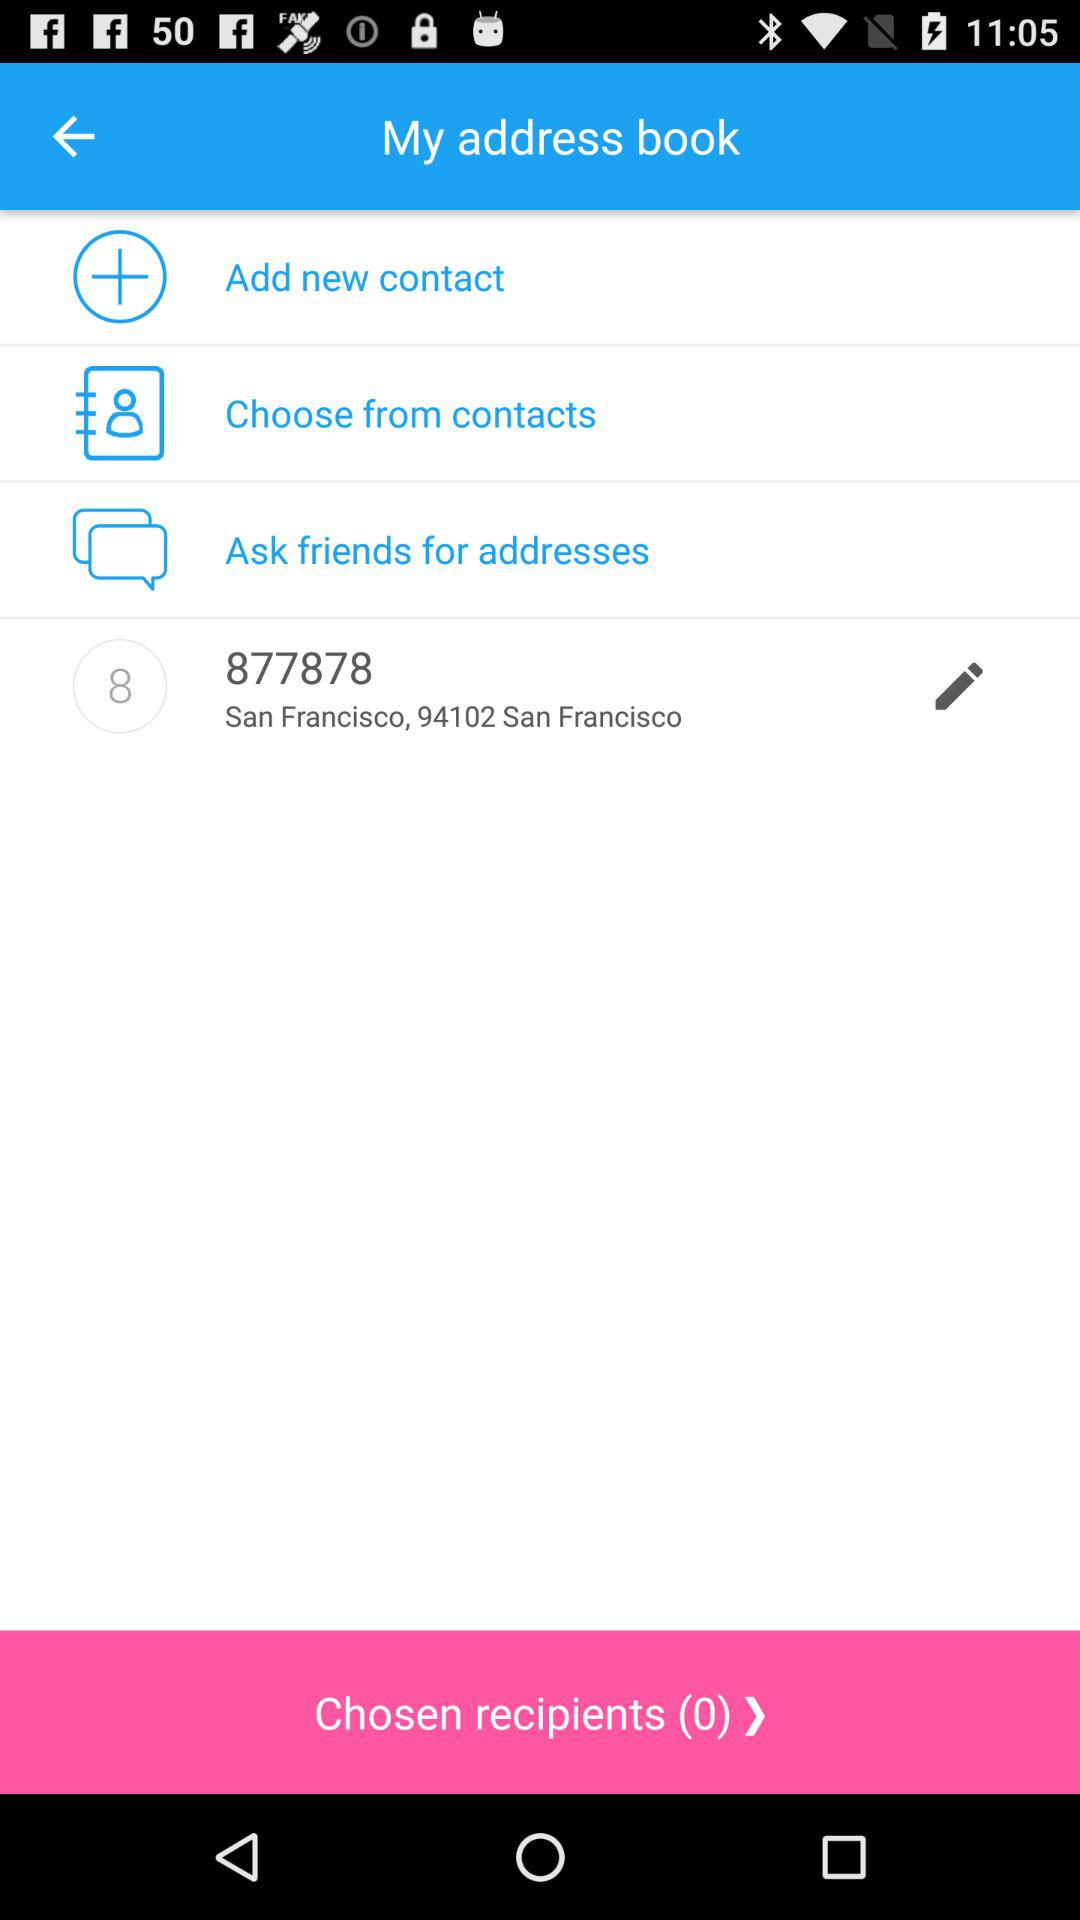What is the location? The location is San Francisco, 94102 San Francisco. 